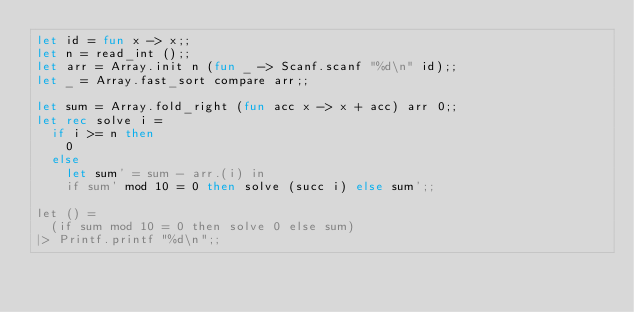<code> <loc_0><loc_0><loc_500><loc_500><_OCaml_>let id = fun x -> x;;
let n = read_int ();;
let arr = Array.init n (fun _ -> Scanf.scanf "%d\n" id);;
let _ = Array.fast_sort compare arr;;

let sum = Array.fold_right (fun acc x -> x + acc) arr 0;;
let rec solve i =
  if i >= n then
    0
  else
    let sum' = sum - arr.(i) in
    if sum' mod 10 = 0 then solve (succ i) else sum';;

let () =
  (if sum mod 10 = 0 then solve 0 else sum)
|> Printf.printf "%d\n";;
</code> 